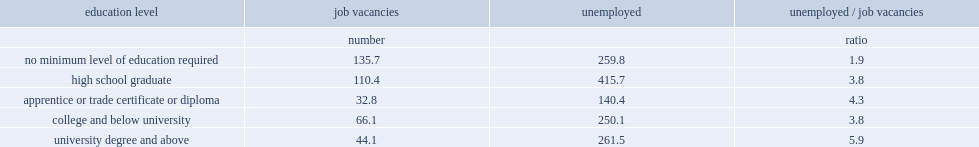How many unemployed persons per job would be opening, if if unemployed university-educated persons restricted their job search only to jobs requiring a university education? 5.9. How many unemployed persons per vacancy wuold be, if restricting vacancies that require a high school education only to those with this level of education? 3.8. What percentage did job vacancies require no more than a high school education? 0.632485. What percentage do unemployed have a postsecondary education? 0.491149. 